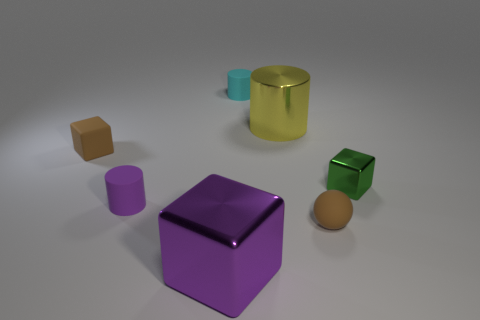There is a object that is the same color as the tiny ball; what is its shape?
Provide a short and direct response. Cube. Is there a blue cube?
Your answer should be compact. No. What is the shape of the brown rubber thing that is on the left side of the cyan rubber object?
Your answer should be compact. Cube. How many small things are in front of the small green metallic object and on the left side of the brown matte sphere?
Give a very brief answer. 1. What number of other objects are there of the same size as the yellow metallic cylinder?
Ensure brevity in your answer.  1. Do the shiny object right of the ball and the brown matte thing that is in front of the green metal thing have the same shape?
Offer a terse response. No. What number of objects are either small blue shiny spheres or purple shiny cubes on the left side of the shiny cylinder?
Give a very brief answer. 1. There is a cube that is behind the sphere and to the left of the tiny shiny cube; what material is it?
Offer a very short reply. Rubber. Are there any other things that have the same shape as the purple rubber object?
Make the answer very short. Yes. What is the color of the cylinder that is the same material as the green object?
Offer a terse response. Yellow. 